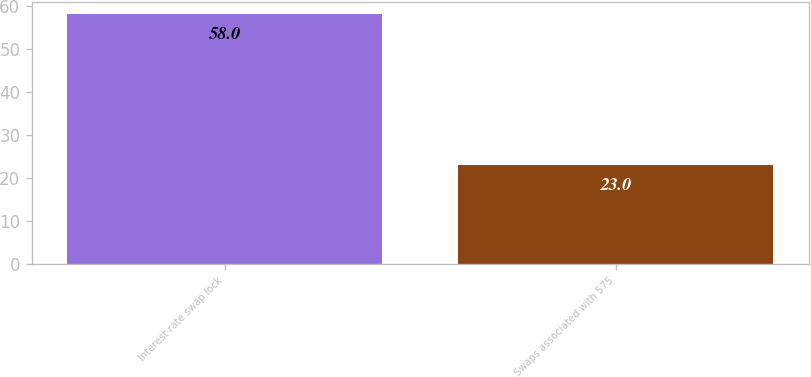<chart> <loc_0><loc_0><loc_500><loc_500><bar_chart><fcel>Interest rate swap lock<fcel>Swaps associated with 575<nl><fcel>58<fcel>23<nl></chart> 